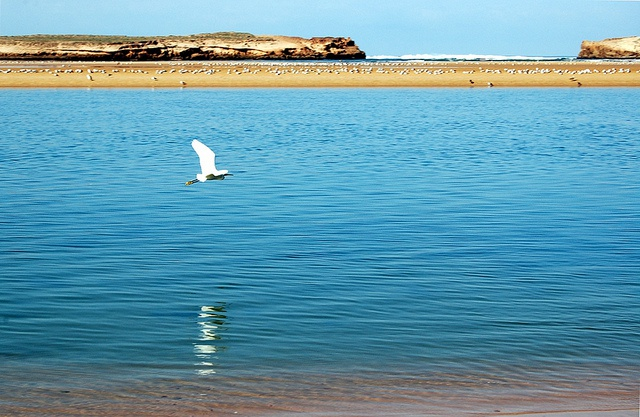Describe the objects in this image and their specific colors. I can see bird in lightblue, white, black, and teal tones, bird in lightblue, black, beige, and teal tones, bird in lightblue, tan, brown, and maroon tones, bird in lightblue, ivory, tan, and brown tones, and bird in lightblue, brown, tan, and maroon tones in this image. 